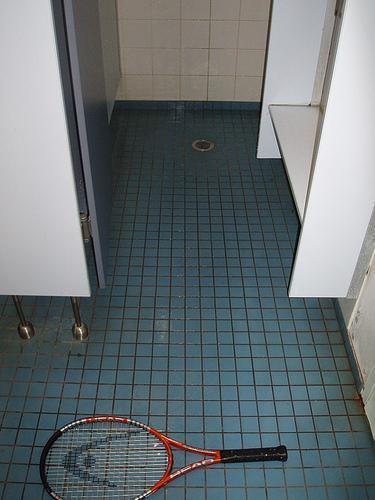How many tennis rackets are there?
Give a very brief answer. 1. 